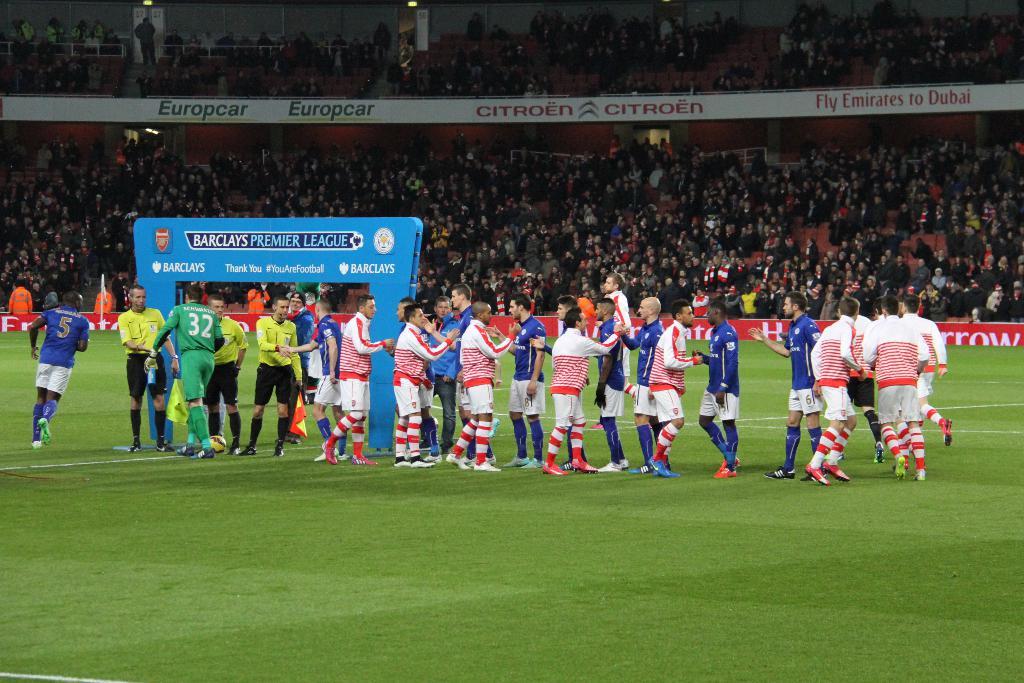What are one of the sponsors of this event?
Your answer should be compact. Europcar. Has the game started?
Provide a short and direct response. No. 